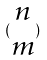<formula> <loc_0><loc_0><loc_500><loc_500>( \begin{matrix} n \\ m \end{matrix} )</formula> 